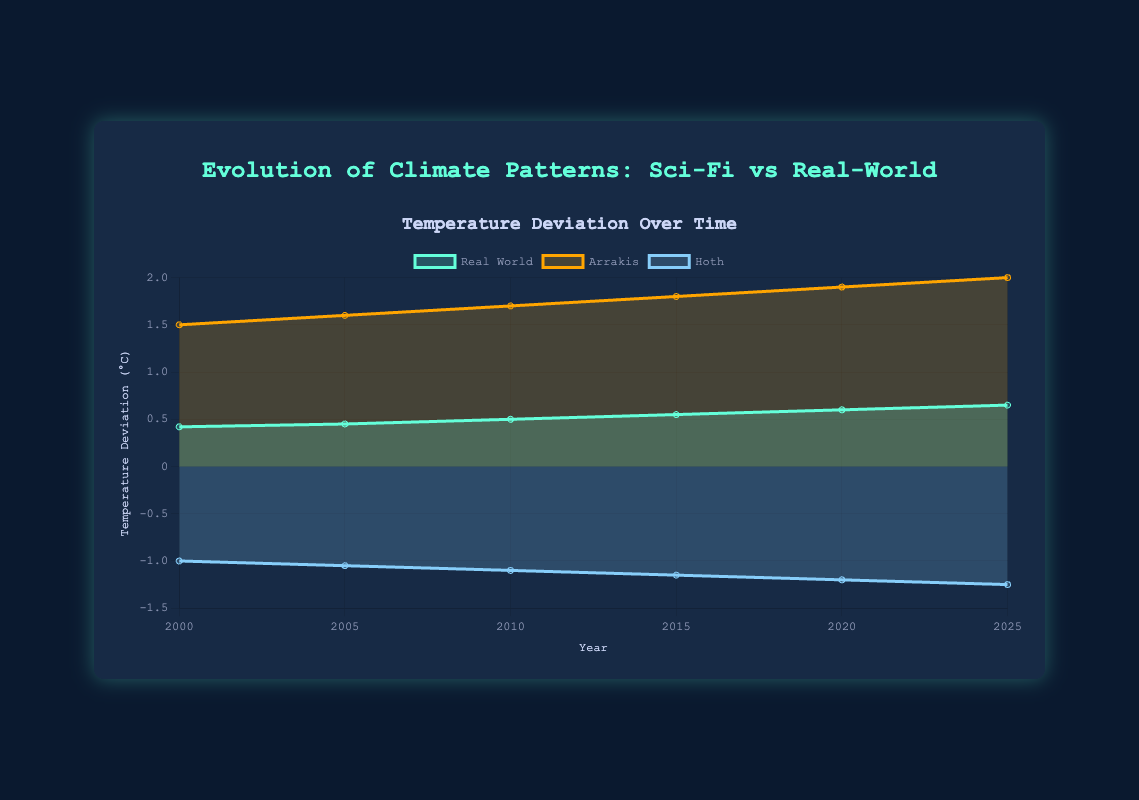How many temperature deviation trends are shown on the chart? There are three different temperature deviation trends shown on the chart: Real World, Arrakis, and Hoth.
Answer: Three What is the title of the chart? The title of the chart is displayed at the top center of the chart and reads "Evolution of Climate Patterns: Sci-Fi vs Real-World."
Answer: Evolution of Climate Patterns: Sci-Fi vs Real-World In what year does the real-world temperature deviation reach 0.6°C? By examining the x-axis for the year and the corresponding value on the y-axis, the real-world temperature deviation reaches 0.6°C in the year 2020.
Answer: 2020 Compare the temperature deviation of Arrakis and Hoth in the year 2005. According to the chart, in the year 2005, Arrakis has a temperature deviation of 1.6°C and Hoth has a temperature deviation of -1.05°C. These values are compared directly by looking at their respective lines on the graph for that year.
Answer: Arrakis: 1.6°C, Hoth: -1.05°C Which world shows the largest increase in temperature deviation from 2000 to 2025? By looking at the start and end points for each world on the y-axis, Arrakis shows the largest increase, from 1.5°C in 2000 to 2.0°C in 2025, totaling an increase of 0.5°C.
Answer: Arrakis What is the difference in real-world temperature deviation between the year 2010 and 2025? The real-world temperature deviation is 0.5°C in 2010 and 0.65°C in 2025. The difference is calculated as 0.65°C - 0.5°C = 0.15°C.
Answer: 0.15°C What trend do you see for the temperature deviation of Hoth over the years 2000 to 2025? Hoth's temperature deviation consistently decreases, starting from -1.0°C in 2000 and reaching -1.25°C in 2025, indicating a trend of cooling over these years.
Answer: Cooling trend Which year shows the smallest temperature deviation for the real-world? By examining the y-axis values for the real-world line, the smallest temperature deviation is in the year 2000, with a value of 0.42°C.
Answer: 2000 Calculate the average temperature deviation for Arrakis across all years shown. The values for Arrakis are 1.5, 1.6, 1.7, 1.8, 1.9, and 2.0. Summing these values gives 10.5. The average is calculated as 10.5 / 6 = 1.75°C.
Answer: 1.75°C 